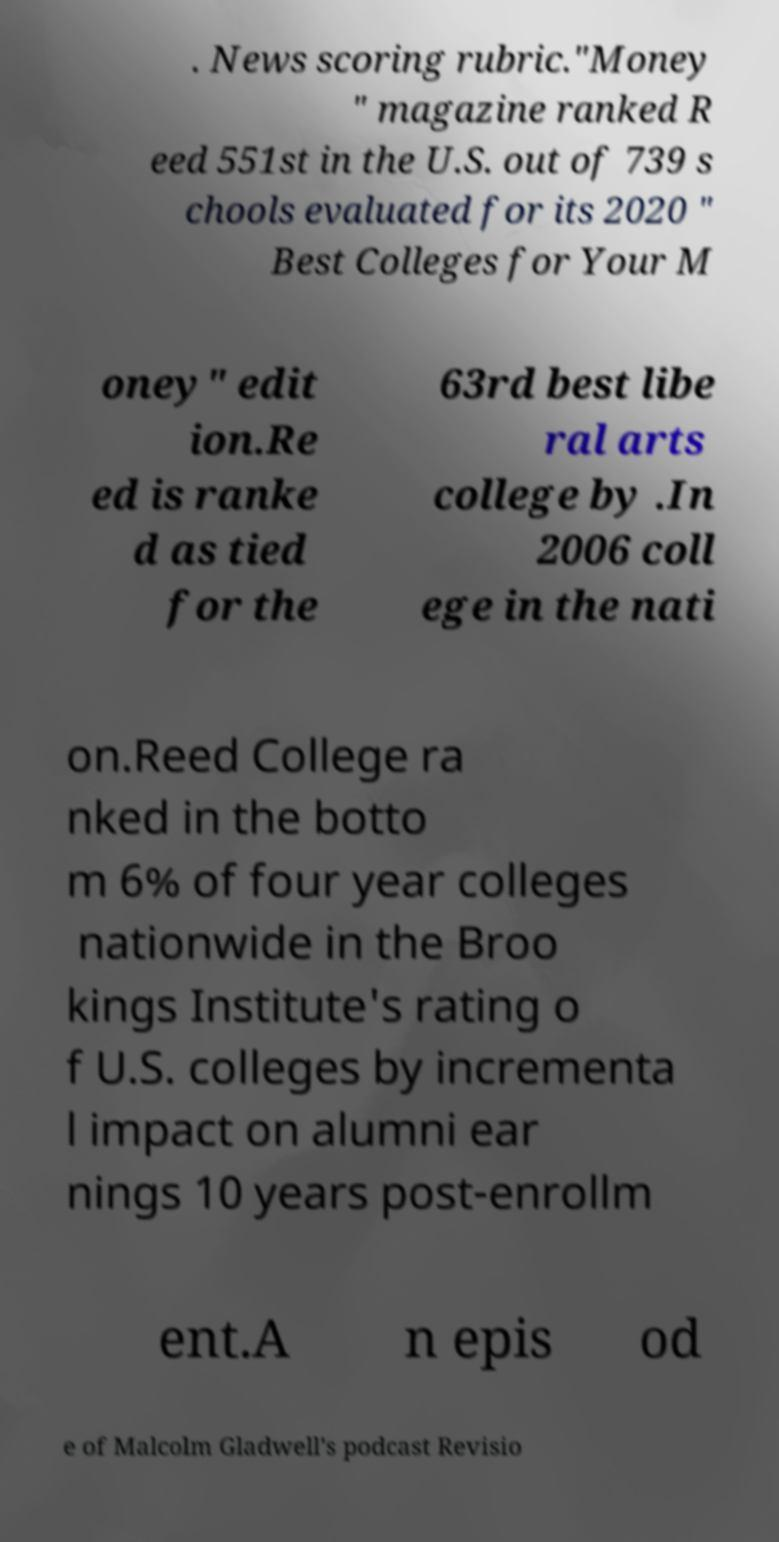Could you extract and type out the text from this image? . News scoring rubric."Money " magazine ranked R eed 551st in the U.S. out of 739 s chools evaluated for its 2020 " Best Colleges for Your M oney" edit ion.Re ed is ranke d as tied for the 63rd best libe ral arts college by .In 2006 coll ege in the nati on.Reed College ra nked in the botto m 6% of four year colleges nationwide in the Broo kings Institute's rating o f U.S. colleges by incrementa l impact on alumni ear nings 10 years post-enrollm ent.A n epis od e of Malcolm Gladwell's podcast Revisio 